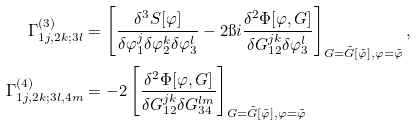Convert formula to latex. <formula><loc_0><loc_0><loc_500><loc_500>\Gamma _ { 1 j , 2 k ; 3 l } ^ { ( 3 ) } & = \left [ \frac { \delta ^ { 3 } S [ \varphi ] } { \delta \varphi _ { 1 } ^ { j } \delta \varphi _ { 2 } ^ { k } \delta \varphi _ { 3 } ^ { l } } - 2 \i i \frac { \delta ^ { 2 } \Phi [ \varphi , G ] } { \delta G _ { 1 2 } ^ { j k } \delta \varphi _ { 3 } ^ { l } } \right ] _ { G = \tilde { G } [ \tilde { \varphi } ] , \varphi = \tilde { \varphi } } , \\ \Gamma _ { 1 j , 2 k ; 3 l , 4 m } ^ { ( 4 ) } & = - 2 \left [ \frac { \delta ^ { 2 } \Phi [ \varphi , G ] } { \delta G _ { 1 2 } ^ { j k } \delta G _ { 3 4 } ^ { l m } } \right ] _ { G = \tilde { G } [ \tilde { \varphi } ] , \varphi = \tilde { \varphi } }</formula> 